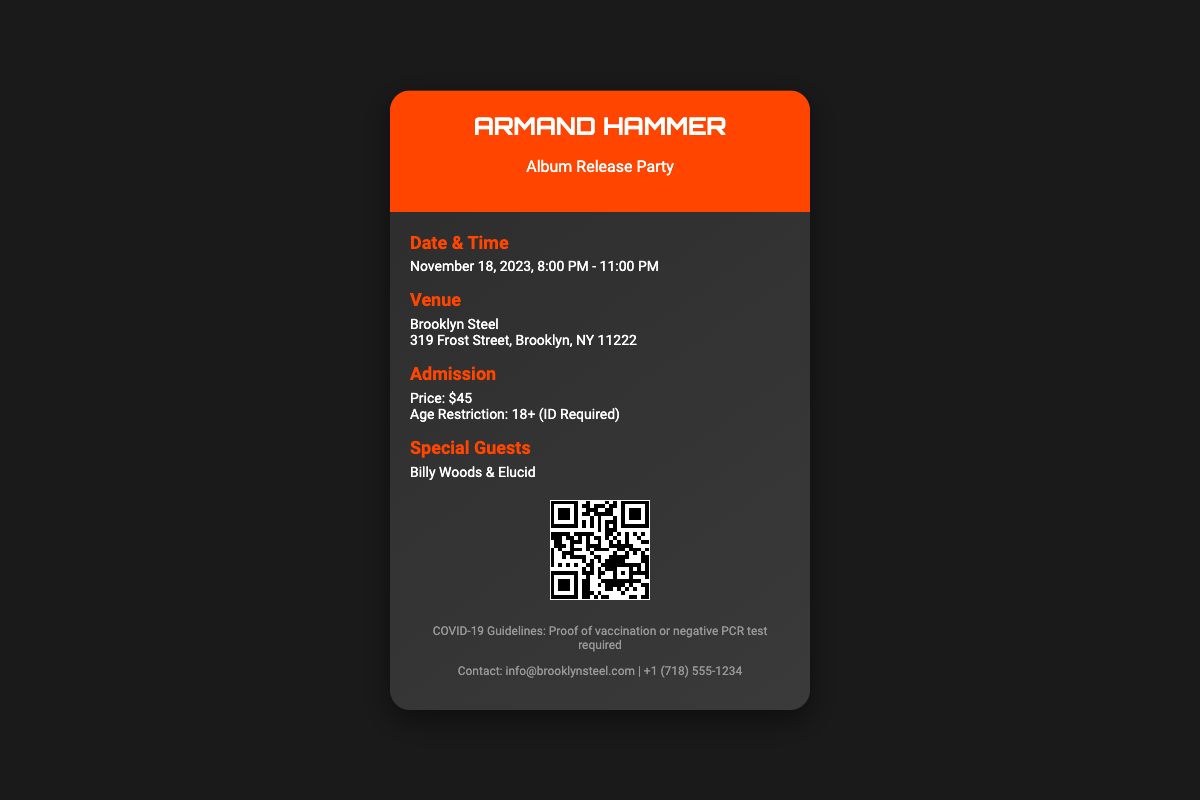What is the date of the event? The date of the event is specified in the document as November 18, 2023.
Answer: November 18, 2023 What time does the event start? The start time of the event is provided as 8:00 PM in the document.
Answer: 8:00 PM What is the admission price? The document states the admission price as $45.
Answer: $45 What is the venue? The venue for the event is mentioned as Brooklyn Steel.
Answer: Brooklyn Steel Who are the special guests? The document lists the special guests as Billy Woods & Elucid.
Answer: Billy Woods & Elucid How many hours is the event? The document indicates the event runs from 8:00 PM to 11:00 PM, which is 3 hours.
Answer: 3 hours What age restriction is mentioned? The age restriction specified in the document is 18+, requiring ID.
Answer: 18+ (ID Required) What COVID-19 guideline is mentioned? The document requires proof of vaccination or negative PCR test as a guideline.
Answer: Proof of vaccination or negative PCR test required What is the contact email provided? The document provides the contact email as info@brooklynsteel.com.
Answer: info@brooklynsteel.com 